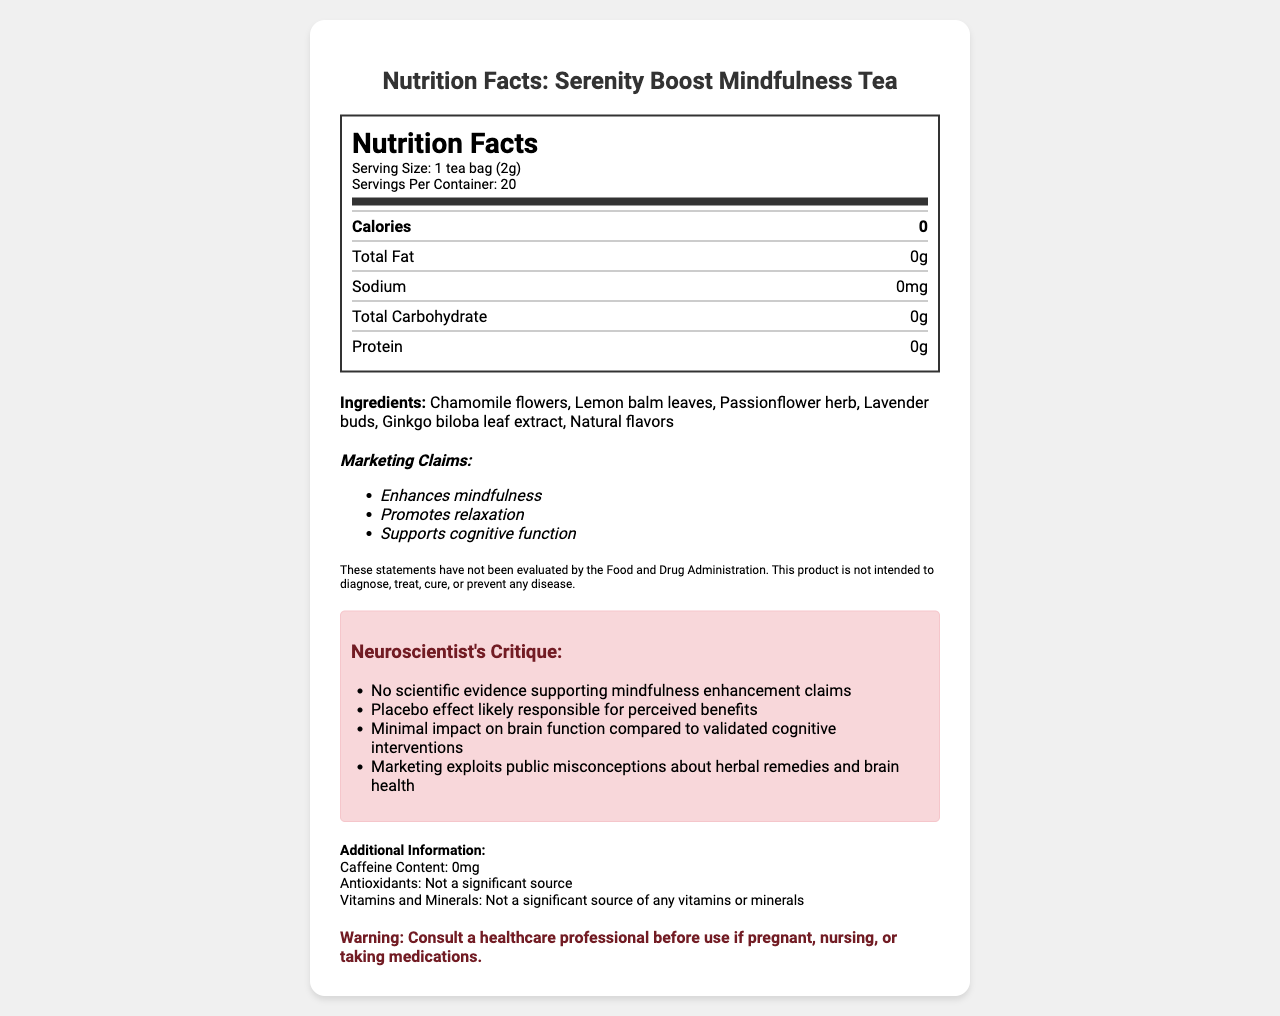what is the serving size of the Serenity Boost Mindfulness Tea? The serving size is explicitly mentioned in the serving information section at the top of the nutrition label.
Answer: 1 tea bag (2g) how many servings are there per container? The number of servings per container is listed alongside the serving size in the nutrition label.
Answer: 20 how many calories does each serving contain? The number of calories per serving is highlighted prominently in the nutrition label.
Answer: 0 list three main ingredients in the Serenity Boost Mindfulness Tea. The main ingredients are listed under the Ingredients section in the document.
Answer: Chamomile flowers, Lemon balm leaves, Passionflower herb what warning is provided regarding the use of this tea? The warning is clearly mentioned at the bottom of the document.
Answer: Consult a healthcare professional before use if pregnant, nursing, or taking medications. does this product contain any fat? The nutrition label states that the total fat content is 0g.
Answer: No summarize the main insights given by the nutrition facts label. The summary covers the key aspects and information provided by the nutrition facts label, including the product's nutritional content, ingredients, marketing claims, scientific critique, additional information, and warning.
Answer: The product is a herbal tea with zero calories, zero fat, zero sodium, zero carbohydrates, and zero protein. It contains ingredients such as chamomile flowers, lemon balm leaves, and ginkgo biloba leaf extract. Marketing claims include enhancing mindfulness and promoting relaxation, but a scientific critique highlights there is no substantial evidence to support these claims. The product has no caffeine, antioxidants, or significant vitamins and minerals, and a warning advises consultation with a healthcare professional if pregnant, nursing, or on medications. what is the total carbohydrate content per serving? The total carbohydrate content is clearly listed as 0g per serving under the nutrition label.
Answer: 0g which ingredient contains an extract? Among the listed ingredients, Ginkgo biloba leaf is the one mentioned as an extract.
Answer: Ginkgo biloba leaf extract are the claims made by the product supported by scientific evidence according to the document? The critique section indicates that there is no scientific evidence supporting the product's mindfulness enhancement claims and that perceived benefits are likely due to the placebo effect.
Answer: No is the antioxident content of this tea significant? The additional information section explicitly states that antioxidants are not a significant source.
Answer: No what scientific critique is provided about the marketing claims of the tea? The critique section points out several issues: lack of scientific evidence for mindfulness enhancement, the placebo effect’s role, minimal impact on brain function compared to validated cognitive interventions, and exploitation of public misconceptions about herbal remedies and brain health.
Answer: No scientific evidence supporting mindfulness enhancement claims, placebo effect likely, minimal impact on brain function, exploits public misconceptions. how much protein is in each serving? The nutrition label clearly states that there is 0g of protein per serving.
Answer: 0g what caffeine content is listed for this tea? The document states that the caffeine content is 0mg in the additional information section.
Answer: 0mg how effective is Serenity Boost Mindfulness Tea in enhancing mindfulness according to the critique? The neuroscientist's critique suggests that the claims of enhancing mindfulness are not supported by scientific evidence and are likely due to a placebo effect.
Answer: Not effective does the document explain the exact mechanisms by which the tea purports to enhance mindfulness? The document does not provide details on the mechanisms by which the tea claims to enhance mindfulness; it only lists the marketing claims and the critique.
Answer: Cannot be determined 